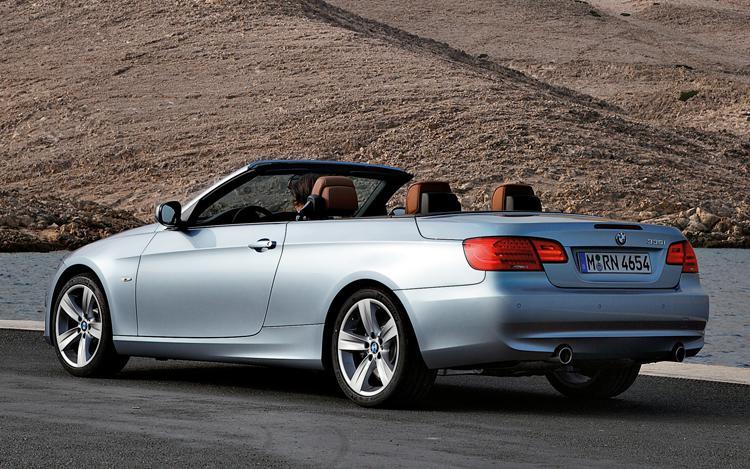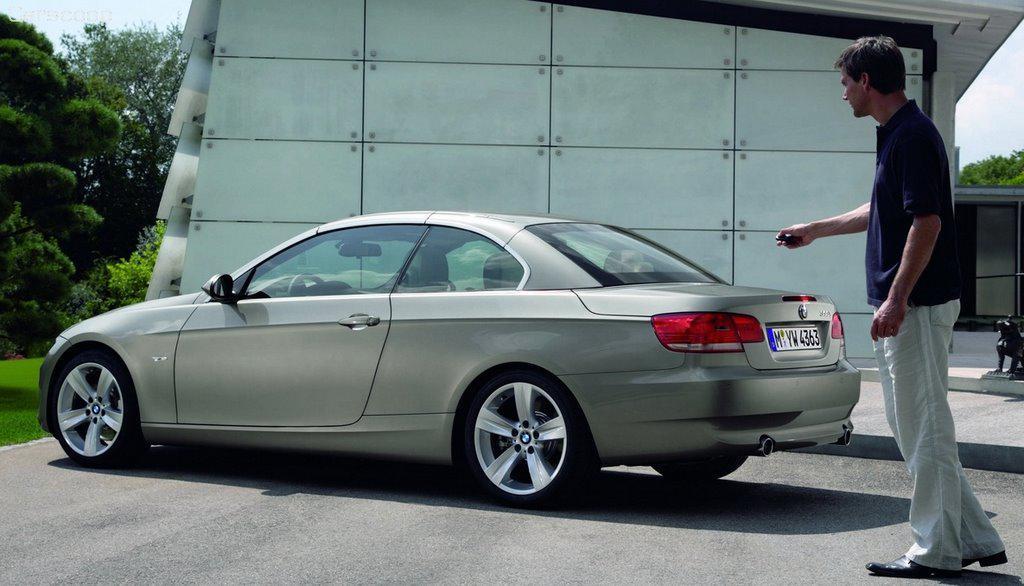The first image is the image on the left, the second image is the image on the right. Examine the images to the left and right. Is the description "both pictures have convertibles in them" accurate? Answer yes or no. No. The first image is the image on the left, the second image is the image on the right. For the images displayed, is the sentence "there is a man standing next to a car in one of the images." factually correct? Answer yes or no. Yes. 